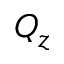<formula> <loc_0><loc_0><loc_500><loc_500>Q _ { z }</formula> 